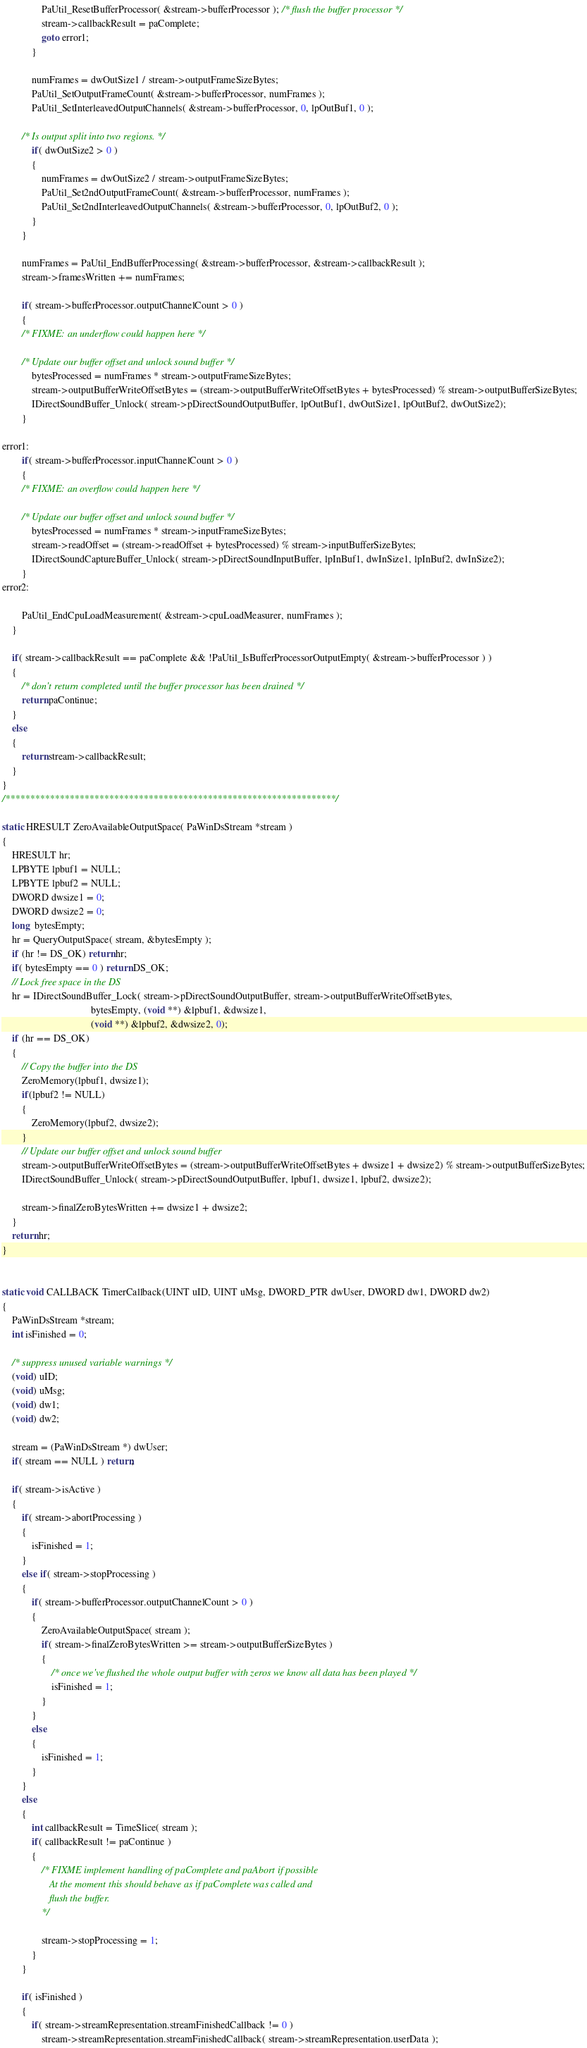<code> <loc_0><loc_0><loc_500><loc_500><_C_>                PaUtil_ResetBufferProcessor( &stream->bufferProcessor ); /* flush the buffer processor */
                stream->callbackResult = paComplete;
                goto error1;
            }

            numFrames = dwOutSize1 / stream->outputFrameSizeBytes;
            PaUtil_SetOutputFrameCount( &stream->bufferProcessor, numFrames );
            PaUtil_SetInterleavedOutputChannels( &stream->bufferProcessor, 0, lpOutBuf1, 0 );

        /* Is output split into two regions. */
            if( dwOutSize2 > 0 )
            {
                numFrames = dwOutSize2 / stream->outputFrameSizeBytes;
                PaUtil_Set2ndOutputFrameCount( &stream->bufferProcessor, numFrames );
                PaUtil_Set2ndInterleavedOutputChannels( &stream->bufferProcessor, 0, lpOutBuf2, 0 );
            }
        }

        numFrames = PaUtil_EndBufferProcessing( &stream->bufferProcessor, &stream->callbackResult );
        stream->framesWritten += numFrames;
        
        if( stream->bufferProcessor.outputChannelCount > 0 )
        {
        /* FIXME: an underflow could happen here */

        /* Update our buffer offset and unlock sound buffer */
            bytesProcessed = numFrames * stream->outputFrameSizeBytes;
            stream->outputBufferWriteOffsetBytes = (stream->outputBufferWriteOffsetBytes + bytesProcessed) % stream->outputBufferSizeBytes;
            IDirectSoundBuffer_Unlock( stream->pDirectSoundOutputBuffer, lpOutBuf1, dwOutSize1, lpOutBuf2, dwOutSize2);
        }

error1:
        if( stream->bufferProcessor.inputChannelCount > 0 )
        {
        /* FIXME: an overflow could happen here */

        /* Update our buffer offset and unlock sound buffer */
            bytesProcessed = numFrames * stream->inputFrameSizeBytes;
            stream->readOffset = (stream->readOffset + bytesProcessed) % stream->inputBufferSizeBytes;
            IDirectSoundCaptureBuffer_Unlock( stream->pDirectSoundInputBuffer, lpInBuf1, dwInSize1, lpInBuf2, dwInSize2);
        }
error2:

        PaUtil_EndCpuLoadMeasurement( &stream->cpuLoadMeasurer, numFrames );        
    }

    if( stream->callbackResult == paComplete && !PaUtil_IsBufferProcessorOutputEmpty( &stream->bufferProcessor ) )
    {
        /* don't return completed until the buffer processor has been drained */
        return paContinue;
    }
    else
    {
        return stream->callbackResult;
    }
}
/*******************************************************************/

static HRESULT ZeroAvailableOutputSpace( PaWinDsStream *stream )
{
    HRESULT hr;
    LPBYTE lpbuf1 = NULL;
    LPBYTE lpbuf2 = NULL;
    DWORD dwsize1 = 0;
    DWORD dwsize2 = 0;
    long  bytesEmpty;
    hr = QueryOutputSpace( stream, &bytesEmpty );
    if (hr != DS_OK) return hr;
    if( bytesEmpty == 0 ) return DS_OK;
    // Lock free space in the DS
    hr = IDirectSoundBuffer_Lock( stream->pDirectSoundOutputBuffer, stream->outputBufferWriteOffsetBytes,
                                    bytesEmpty, (void **) &lpbuf1, &dwsize1,
                                    (void **) &lpbuf2, &dwsize2, 0);
    if (hr == DS_OK)
    {
        // Copy the buffer into the DS
        ZeroMemory(lpbuf1, dwsize1);
        if(lpbuf2 != NULL)
        {
            ZeroMemory(lpbuf2, dwsize2);
        }
        // Update our buffer offset and unlock sound buffer
        stream->outputBufferWriteOffsetBytes = (stream->outputBufferWriteOffsetBytes + dwsize1 + dwsize2) % stream->outputBufferSizeBytes;
        IDirectSoundBuffer_Unlock( stream->pDirectSoundOutputBuffer, lpbuf1, dwsize1, lpbuf2, dwsize2);

        stream->finalZeroBytesWritten += dwsize1 + dwsize2;
    }
    return hr;
}


static void CALLBACK TimerCallback(UINT uID, UINT uMsg, DWORD_PTR dwUser, DWORD dw1, DWORD dw2)
{
    PaWinDsStream *stream;
    int isFinished = 0;

    /* suppress unused variable warnings */
    (void) uID;
    (void) uMsg;
    (void) dw1;
    (void) dw2;
    
    stream = (PaWinDsStream *) dwUser;
    if( stream == NULL ) return;

    if( stream->isActive )
    {
        if( stream->abortProcessing )
        {
            isFinished = 1;
        }
        else if( stream->stopProcessing )
        {
            if( stream->bufferProcessor.outputChannelCount > 0 )
            {
                ZeroAvailableOutputSpace( stream );
                if( stream->finalZeroBytesWritten >= stream->outputBufferSizeBytes )
                {
                    /* once we've flushed the whole output buffer with zeros we know all data has been played */
                    isFinished = 1;
                }
            }
            else
            {
                isFinished = 1;
            }
        }
        else
        {
            int callbackResult = TimeSlice( stream );
            if( callbackResult != paContinue )
            {
                /* FIXME implement handling of paComplete and paAbort if possible 
                   At the moment this should behave as if paComplete was called and 
                   flush the buffer.
                */

                stream->stopProcessing = 1;
            }
        }

        if( isFinished )
        {
            if( stream->streamRepresentation.streamFinishedCallback != 0 )
                stream->streamRepresentation.streamFinishedCallback( stream->streamRepresentation.userData );
</code> 